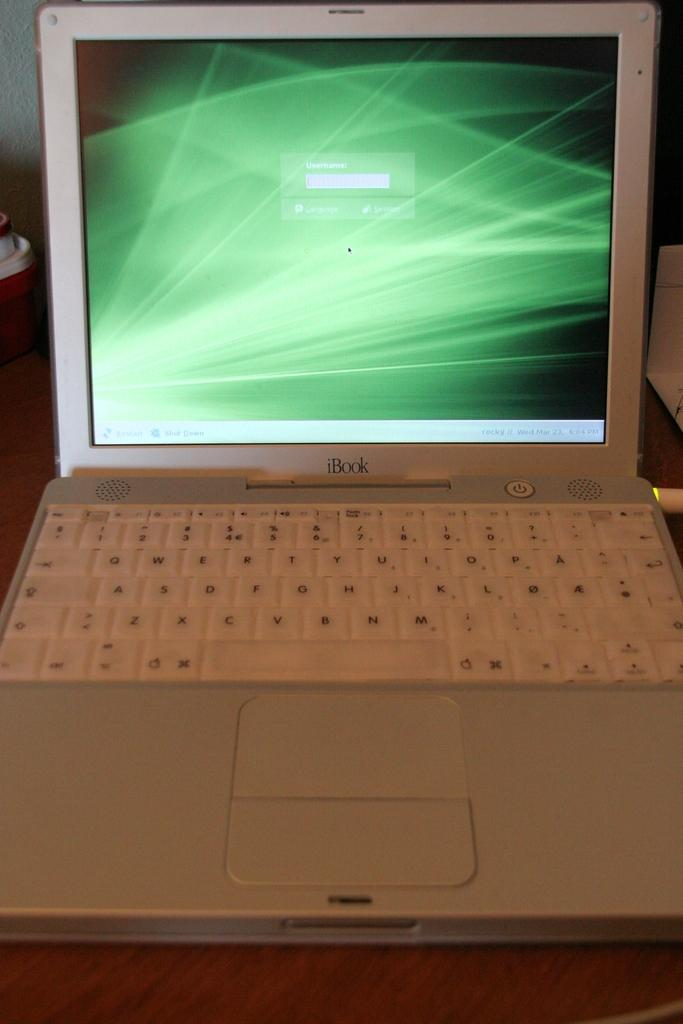<image>
Offer a succinct explanation of the picture presented. A white iBook placed on a wooden desk. 